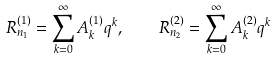<formula> <loc_0><loc_0><loc_500><loc_500>R ^ { ( 1 ) } _ { n _ { 1 } } = \sum _ { k = 0 } ^ { \infty } A ^ { ( 1 ) } _ { k } q ^ { k } , \quad R ^ { ( 2 ) } _ { n _ { 2 } } = \sum _ { k = 0 } ^ { \infty } A ^ { ( 2 ) } _ { k } q ^ { k }</formula> 